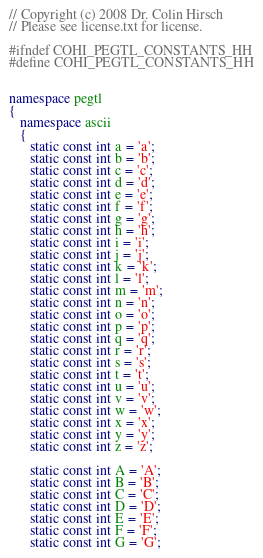Convert code to text. <code><loc_0><loc_0><loc_500><loc_500><_C++_>// Copyright (c) 2008 Dr. Colin Hirsch 
// Please see license.txt for license.

#ifndef COHI_PEGTL_CONSTANTS_HH
#define COHI_PEGTL_CONSTANTS_HH


namespace pegtl
{
   namespace ascii
   {
      static const int a = 'a';
      static const int b = 'b';
      static const int c = 'c';
      static const int d = 'd';
      static const int e = 'e';
      static const int f = 'f';
      static const int g = 'g';
      static const int h = 'h';
      static const int i = 'i';
      static const int j = 'j';
      static const int k = 'k';
      static const int l = 'l';
      static const int m = 'm';
      static const int n = 'n';
      static const int o = 'o';
      static const int p = 'p';
      static const int q = 'q';
      static const int r = 'r';
      static const int s = 's';
      static const int t = 't';
      static const int u = 'u';
      static const int v = 'v';
      static const int w = 'w';
      static const int x = 'x';
      static const int y = 'y';
      static const int z = 'z';

      static const int A = 'A';
      static const int B = 'B';
      static const int C = 'C';
      static const int D = 'D';
      static const int E = 'E';
      static const int F = 'F';
      static const int G = 'G';</code> 